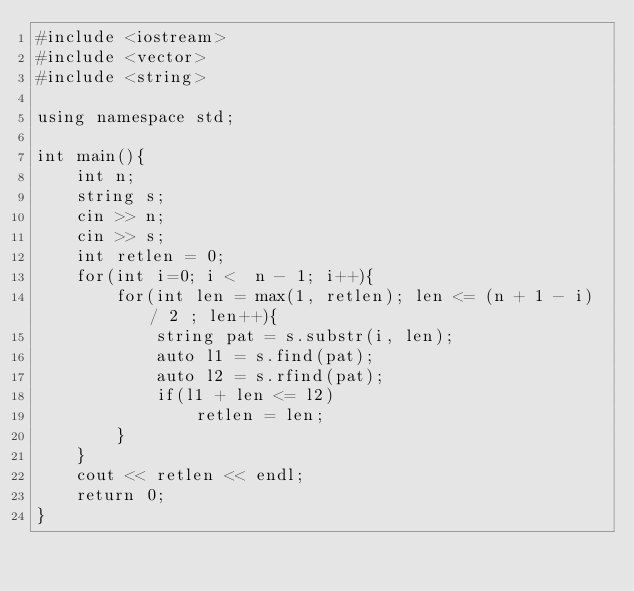Convert code to text. <code><loc_0><loc_0><loc_500><loc_500><_C++_>#include <iostream>
#include <vector>
#include <string>

using namespace std;

int main(){
    int n;
    string s;
    cin >> n;
    cin >> s;
    int retlen = 0;
    for(int i=0; i <  n - 1; i++){
        for(int len = max(1, retlen); len <= (n + 1 - i) / 2 ; len++){
            string pat = s.substr(i, len);
            auto l1 = s.find(pat);
            auto l2 = s.rfind(pat);
            if(l1 + len <= l2)
                retlen = len;
        }
    }
    cout << retlen << endl;
    return 0;
}</code> 